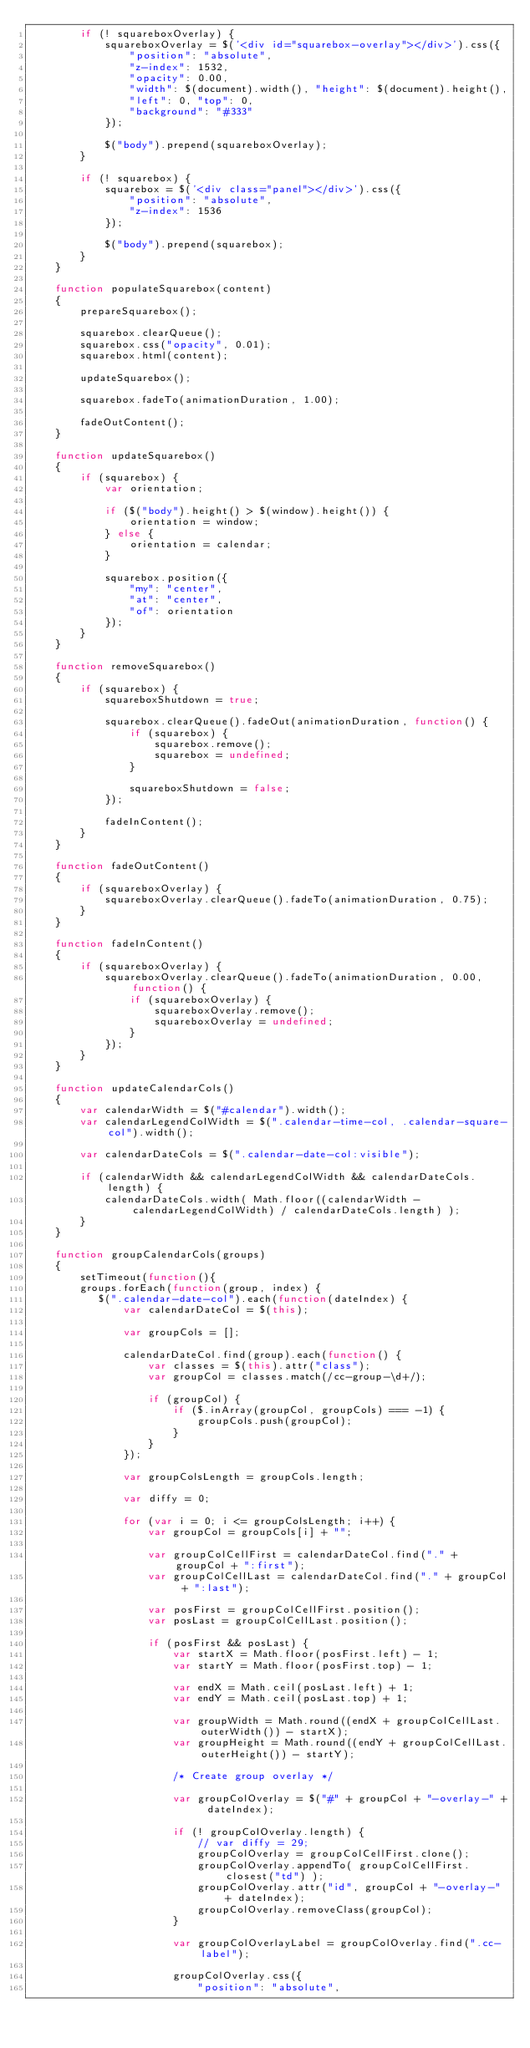Convert code to text. <code><loc_0><loc_0><loc_500><loc_500><_JavaScript_>        if (! squareboxOverlay) {
            squareboxOverlay = $('<div id="squarebox-overlay"></div>').css({
                "position": "absolute",
                "z-index": 1532,
                "opacity": 0.00,
                "width": $(document).width(), "height": $(document).height(),
                "left": 0, "top": 0,
                "background": "#333"
            });

            $("body").prepend(squareboxOverlay);
        }

        if (! squarebox) {
            squarebox = $('<div class="panel"></div>').css({
                "position": "absolute",
                "z-index": 1536
            });

            $("body").prepend(squarebox);
        }
    }

    function populateSquarebox(content)
    {
        prepareSquarebox();

        squarebox.clearQueue();
        squarebox.css("opacity", 0.01);
        squarebox.html(content);

        updateSquarebox();

        squarebox.fadeTo(animationDuration, 1.00);

        fadeOutContent();
    }

    function updateSquarebox()
    {
        if (squarebox) {
            var orientation;

            if ($("body").height() > $(window).height()) {
                orientation = window;
            } else {
                orientation = calendar;
            }

            squarebox.position({
                "my": "center",
                "at": "center",
                "of": orientation
            });
        }
    }

    function removeSquarebox()
    {
        if (squarebox) {
            squareboxShutdown = true;

            squarebox.clearQueue().fadeOut(animationDuration, function() {
                if (squarebox) {
                    squarebox.remove();
                    squarebox = undefined;
                }

                squareboxShutdown = false;
            });

            fadeInContent();
        }
    }

    function fadeOutContent()
    {
        if (squareboxOverlay) {
            squareboxOverlay.clearQueue().fadeTo(animationDuration, 0.75);
        }
    }

    function fadeInContent()
    {
        if (squareboxOverlay) {
            squareboxOverlay.clearQueue().fadeTo(animationDuration, 0.00, function() {
                if (squareboxOverlay) {
                    squareboxOverlay.remove();
                    squareboxOverlay = undefined;
                }
            });
        }
    }

    function updateCalendarCols()
    {
        var calendarWidth = $("#calendar").width();
        var calendarLegendColWidth = $(".calendar-time-col, .calendar-square-col").width();

        var calendarDateCols = $(".calendar-date-col:visible");

        if (calendarWidth && calendarLegendColWidth && calendarDateCols.length) {
            calendarDateCols.width( Math.floor((calendarWidth - calendarLegendColWidth) / calendarDateCols.length) );
        }
    }

    function groupCalendarCols(groups)
    {
        setTimeout(function(){ 
        groups.forEach(function(group, index) {
           $(".calendar-date-col").each(function(dateIndex) {
               var calendarDateCol = $(this);
   
               var groupCols = [];
   
               calendarDateCol.find(group).each(function() {
                   var classes = $(this).attr("class");
                   var groupCol = classes.match(/cc-group-\d+/);
   
                   if (groupCol) {
                       if ($.inArray(groupCol, groupCols) === -1) {
                           groupCols.push(groupCol);
                       }
                   }
               });
   
               var groupColsLength = groupCols.length;
   
               var diffy = 0;
   
               for (var i = 0; i <= groupColsLength; i++) {
                   var groupCol = groupCols[i] + "";
   
                   var groupColCellFirst = calendarDateCol.find("." + groupCol + ":first");
                   var groupColCellLast = calendarDateCol.find("." + groupCol + ":last");
   
                   var posFirst = groupColCellFirst.position();
                   var posLast = groupColCellLast.position();
   
                   if (posFirst && posLast) {
                       var startX = Math.floor(posFirst.left) - 1;
                       var startY = Math.floor(posFirst.top) - 1;
   
                       var endX = Math.ceil(posLast.left) + 1;
                       var endY = Math.ceil(posLast.top) + 1;
   
                       var groupWidth = Math.round((endX + groupColCellLast.outerWidth()) - startX);
                       var groupHeight = Math.round((endY + groupColCellLast.outerHeight()) - startY);
   
                       /* Create group overlay */
   
                       var groupColOverlay = $("#" + groupCol + "-overlay-" + dateIndex);
   
                       if (! groupColOverlay.length) {
                           // var diffy = 29;
                           groupColOverlay = groupColCellFirst.clone();
                           groupColOverlay.appendTo( groupColCellFirst.closest("td") );
                           groupColOverlay.attr("id", groupCol + "-overlay-" + dateIndex);
                           groupColOverlay.removeClass(groupCol);
                       }
   
                       var groupColOverlayLabel = groupColOverlay.find(".cc-label");
   
                       groupColOverlay.css({
                           "position": "absolute",</code> 